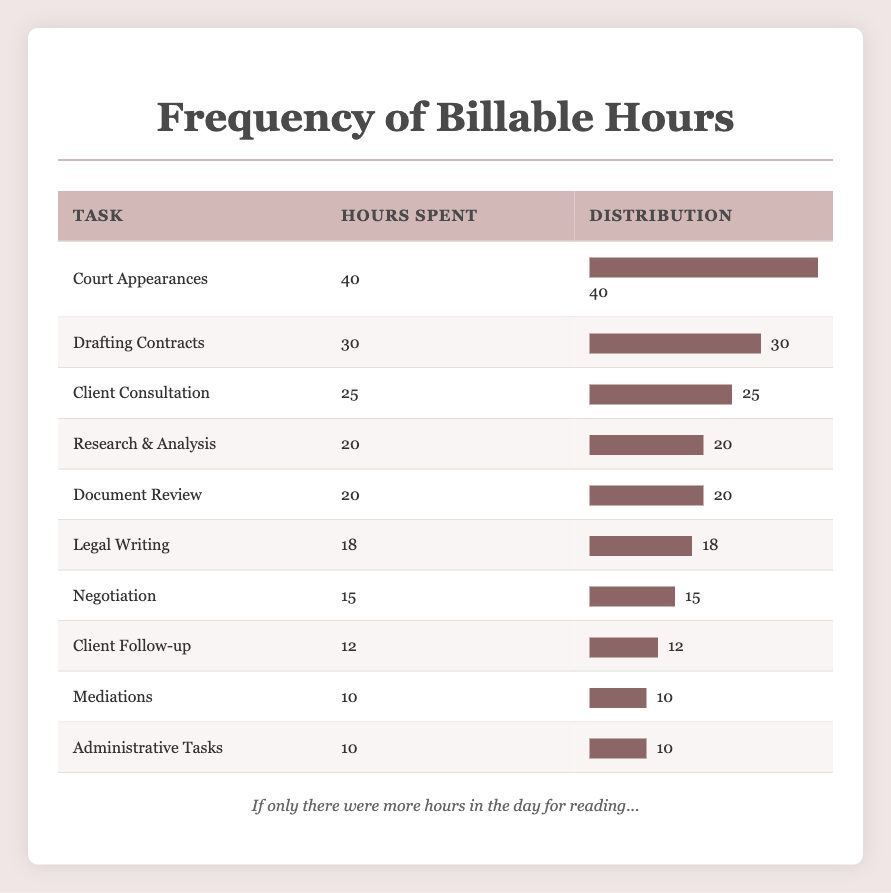What is the total number of billable hours for Client Consultation? According to the table, the hours spent on Client Consultation is explicitly listed as 25 hours.
Answer: 25 Which task has the highest number of billable hours? The task with the highest hours is Court Appearances, which has 40 hours spent, as shown in the table.
Answer: Court Appearances What is the difference in hours spent between Drafting Contracts and Legal Writing? The hours for Drafting Contracts is 30, and for Legal Writing, it is 18. The difference is 30 - 18 = 12 hours.
Answer: 12 Is the total number of hours spent on Mediations equal to that spent on Administrative Tasks? Both Mediations and Administrative Tasks have 10 hours listed in the table, so the statement is true.
Answer: Yes What is the average hours spent on the top three tasks in terms of hours spent? The top three tasks are Court Appearances (40), Drafting Contracts (30), and Client Consultation (25). The total hours are 40 + 30 + 25 = 95. The average is 95 / 3 = 31.67 hours.
Answer: 31.67 How many tasks have billable hours greater than or equal to 20? The tasks with hours greater than or equal to 20 are Client Consultation (25), Drafting Contracts (30), Court Appearances (40), Research & Analysis (20), and Document Review (20), totaling 5 tasks.
Answer: 5 Which task has the least amount of billable hours, and how many hours is that? The task with the least billable hours is Mediations, with 10 hours spent, as shown in the table.
Answer: Mediations, 10 What percentage of the total hours does Negotiation represent? First, sum all hours: 25 + 30 + 20 + 40 + 15 + 10 + 20 + 18 + 12 + 10 =  250 hours total. Negotiation has 15 hours. The percentage is (15 / 250) * 100 = 6%.
Answer: 6% 